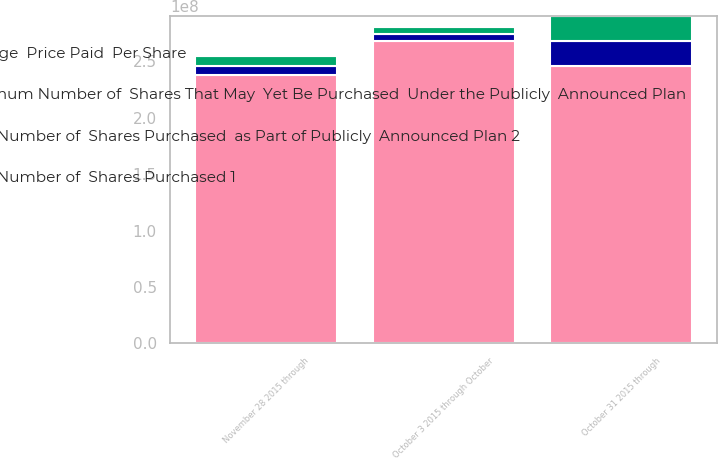Convert chart to OTSL. <chart><loc_0><loc_0><loc_500><loc_500><stacked_bar_chart><ecel><fcel>October 3 2015 through October<fcel>October 31 2015 through<fcel>November 28 2015 through<nl><fcel>Total Number of  Shares Purchased  as Part of Publicly  Announced Plan 2<fcel>6.24756e+06<fcel>2.2031e+07<fcel>8.21044e+06<nl><fcel>Total Number of  Shares Purchased 1<fcel>42.5<fcel>42.28<fcel>42.95<nl><fcel>Maximum Number of  Shares That May  Yet Be Purchased  Under the Publicly  Announced Plan<fcel>6.0242e+06<fcel>2.20273e+07<fcel>8.20973e+06<nl><fcel>Average  Price Paid  Per Share<fcel>2.68169e+08<fcel>2.46142e+08<fcel>2.37932e+08<nl></chart> 